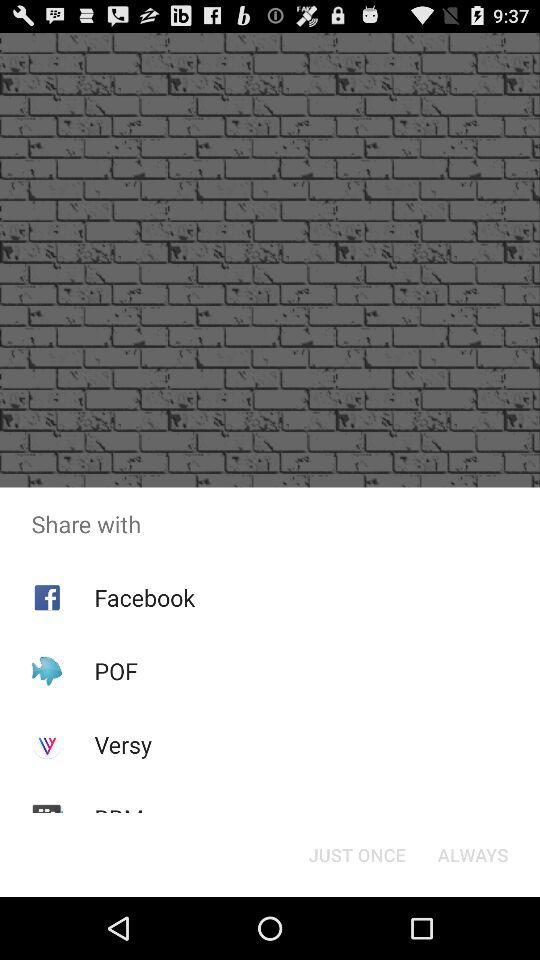Through what applications can users share it? Users can share with "Facebook", "POF" and "Versy". 